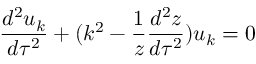<formula> <loc_0><loc_0><loc_500><loc_500>\frac { d ^ { 2 } u _ { k } } { d \tau ^ { 2 } } + ( k ^ { 2 } - \frac { 1 } { z } \frac { d ^ { 2 } z } { d \tau ^ { 2 } } ) u _ { k } = 0</formula> 